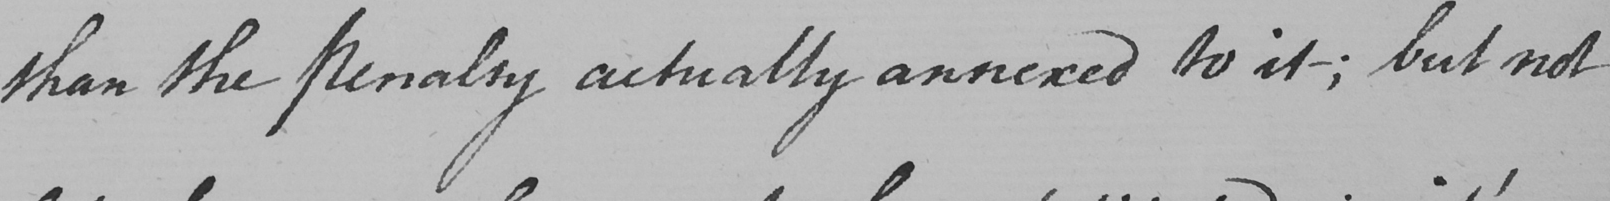What does this handwritten line say? than the Penalty actually annexed to it _  ; but not 